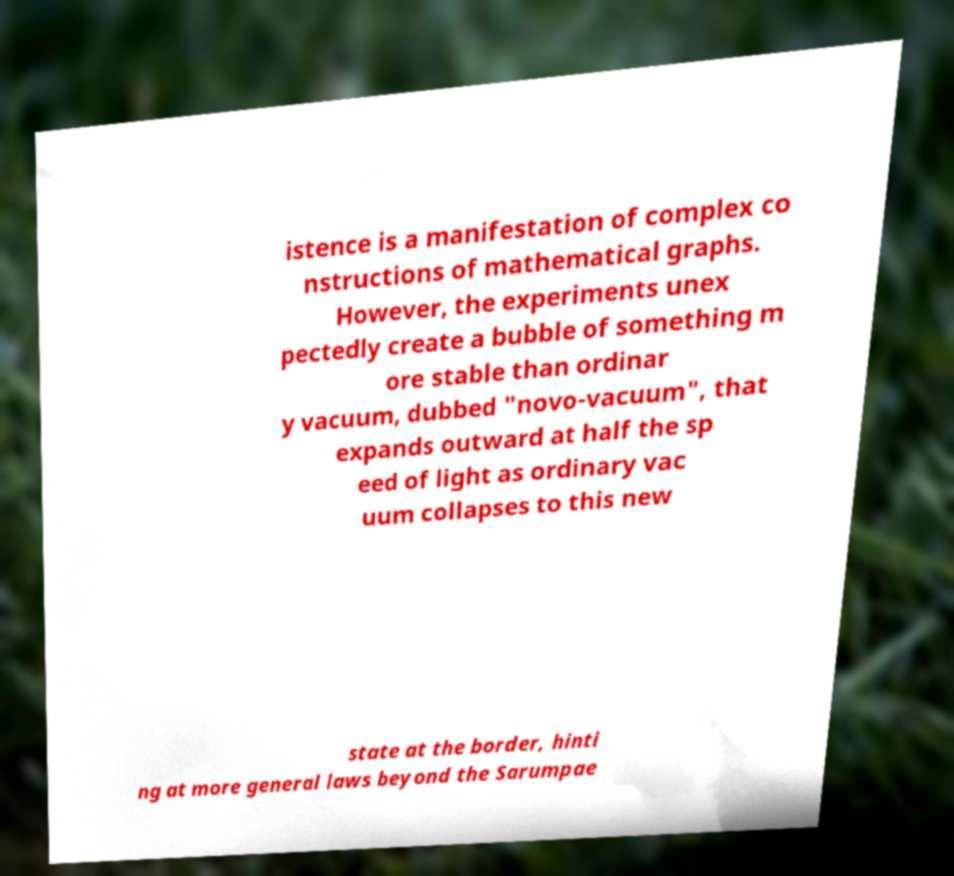Please identify and transcribe the text found in this image. istence is a manifestation of complex co nstructions of mathematical graphs. However, the experiments unex pectedly create a bubble of something m ore stable than ordinar y vacuum, dubbed "novo-vacuum", that expands outward at half the sp eed of light as ordinary vac uum collapses to this new state at the border, hinti ng at more general laws beyond the Sarumpae 